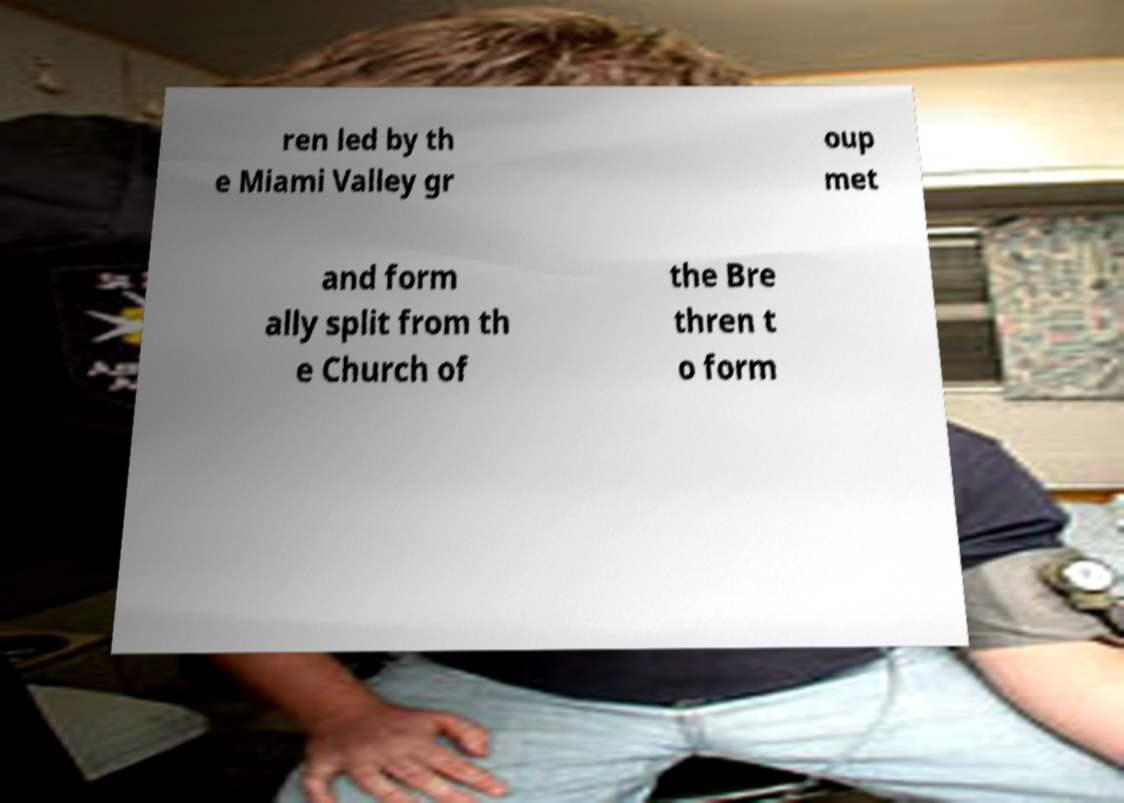Please identify and transcribe the text found in this image. ren led by th e Miami Valley gr oup met and form ally split from th e Church of the Bre thren t o form 